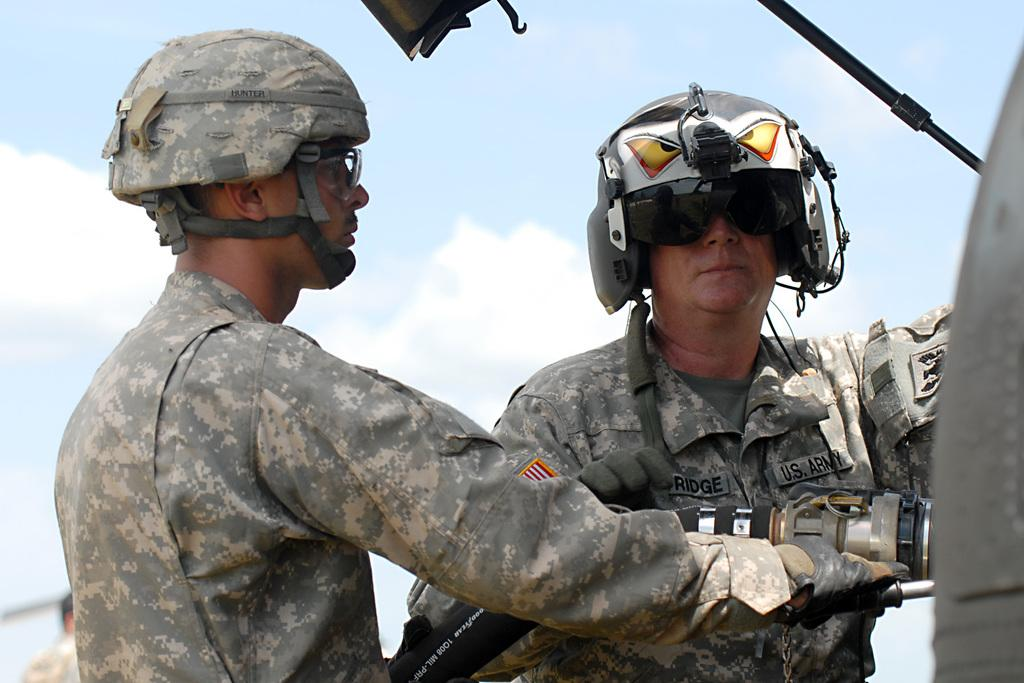What can be seen in the image? There is a group of people in the image. What are some of the people in the group wearing? Some people in the group are wearing helmets. Can you describe the man on the left side of the image? The man on the left side of the image is holding a pipe. What type of company is the fan promoting in the image? There is no fan present in the image, so it is not possible to determine what company they might be promoting. 